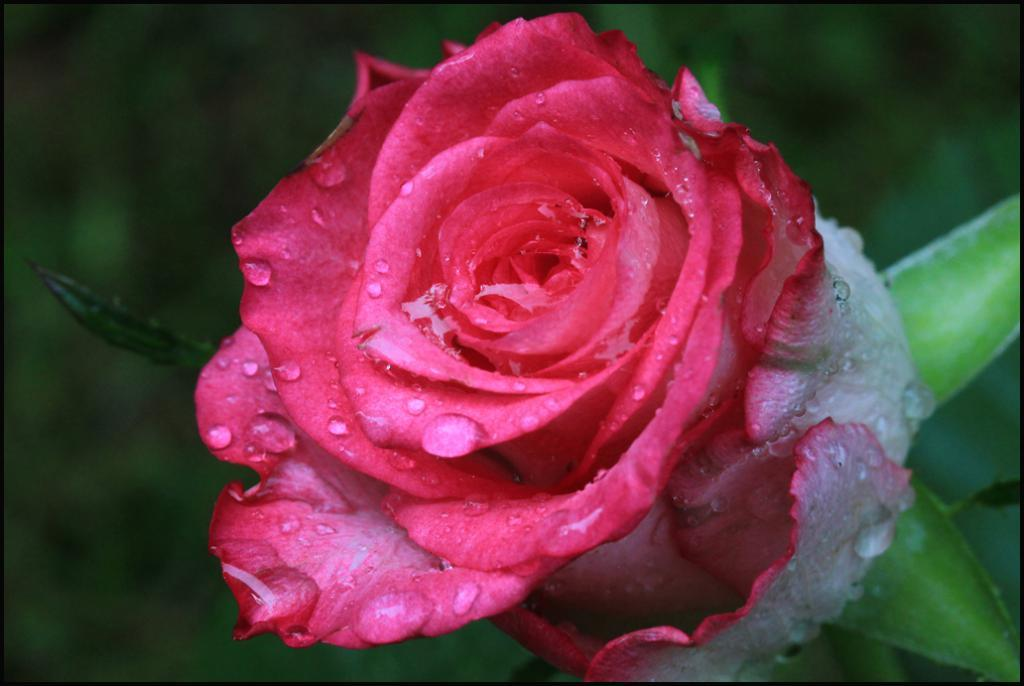What type of flower is in the image? There is a rose flower in the image. Can you describe the appearance of the rose flower? The rose flower has water droplets on it. What type of smoke can be seen coming from the rabbits in the image? There are no rabbits or smoke present in the image; it features a rose flower with water droplets. 